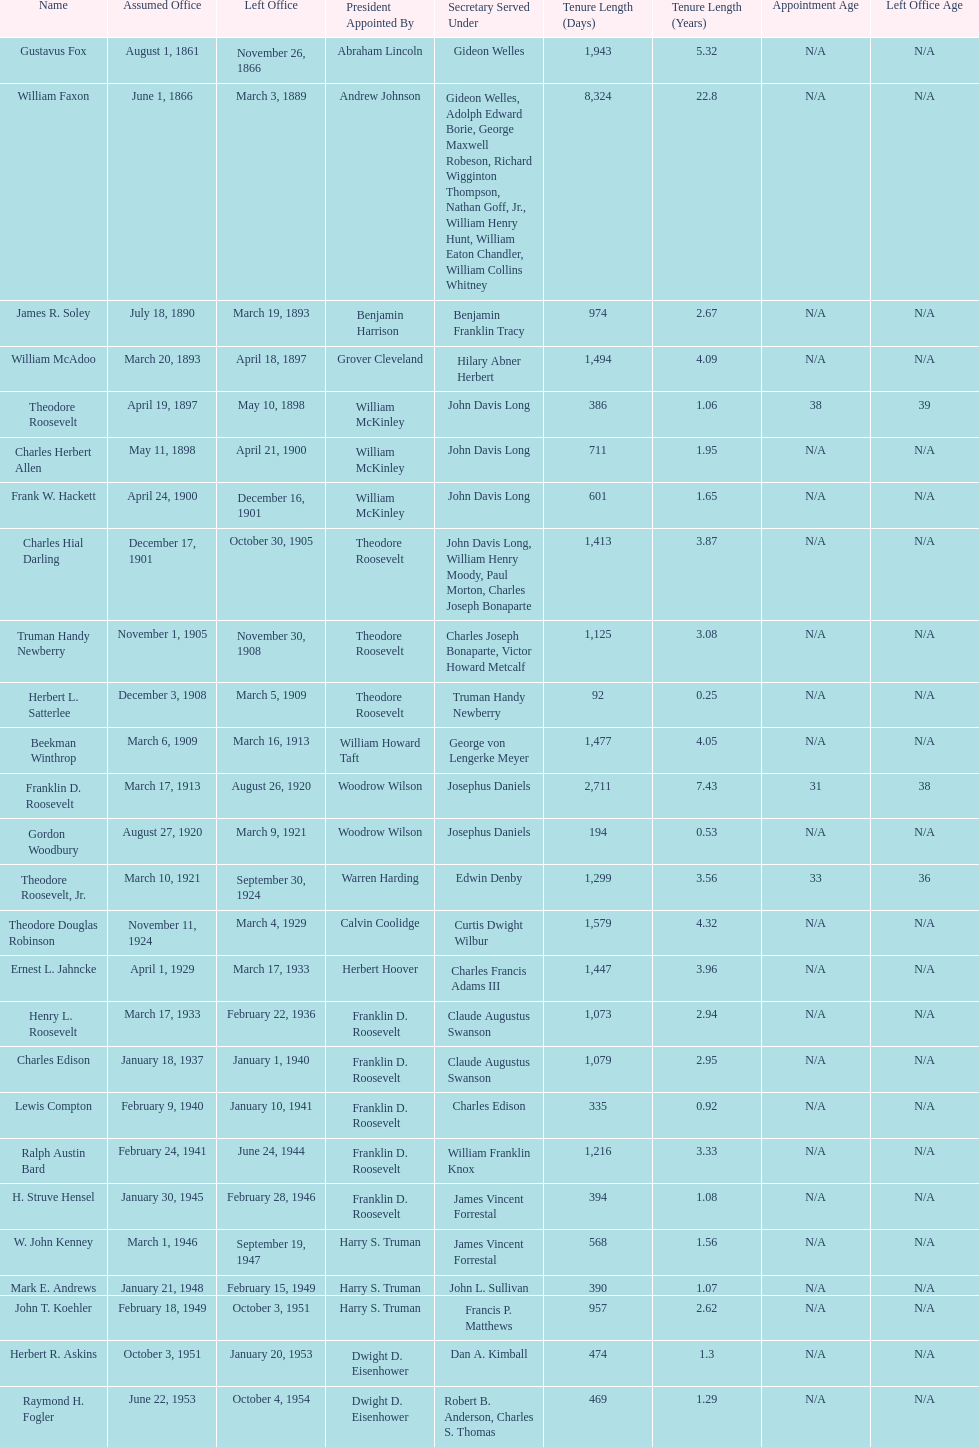Who was the first assistant secretary of the navy? Gustavus Fox. 